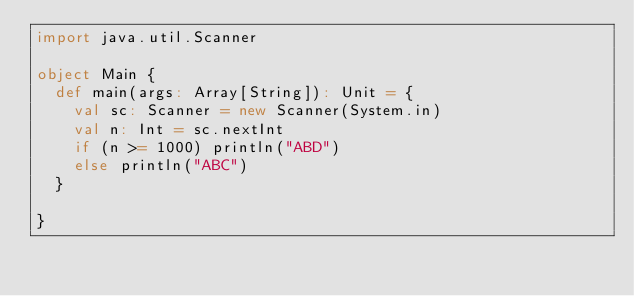Convert code to text. <code><loc_0><loc_0><loc_500><loc_500><_Scala_>import java.util.Scanner

object Main {
  def main(args: Array[String]): Unit = {
    val sc: Scanner = new Scanner(System.in)
    val n: Int = sc.nextInt
    if (n >= 1000) println("ABD")
    else println("ABC")
  }

}
</code> 